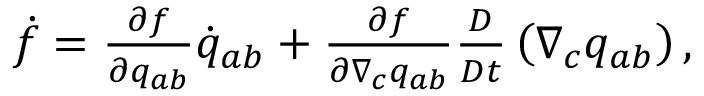Convert formula to latex. <formula><loc_0><loc_0><loc_500><loc_500>\begin{array} { r } { \dot { f } = \frac { \partial f } { \partial q _ { a b } } \dot { q } _ { a b } + \frac { \partial f } { \partial \nabla _ { c } q _ { a b } } \frac { D } { D t } \left ( \nabla _ { c } q _ { a b } \right ) , } \end{array}</formula> 